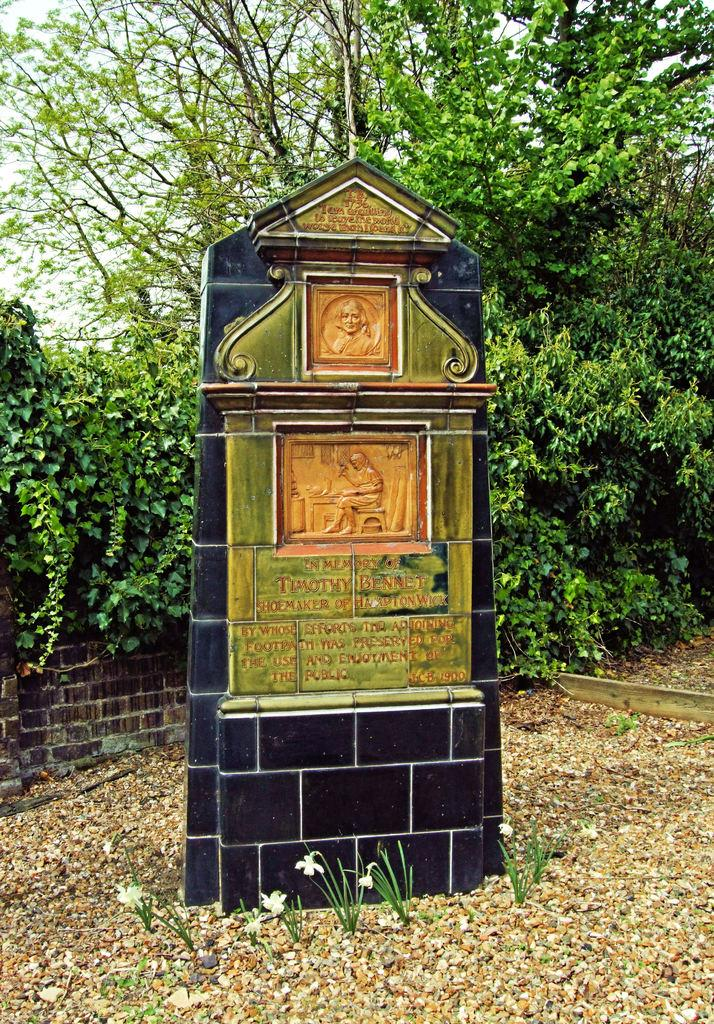What is the main subject of the image? There is a memorial in the image. What type of vegetation can be seen in the image? There are plants, flowers, and trees in the image. What other objects are present in the image? There are stones and a wall in the image. What can be seen in the background of the image? The sky is visible in the background of the image. What color is the coat hanging on the wall in the image? There is no coat present in the image; it only features a memorial, plants, flowers, stones, a wall, trees, and the sky. Can you describe the pattern on the brick used to build the wall in the image? There is no brick visible in the image; the wall appears to be made of a different material. 